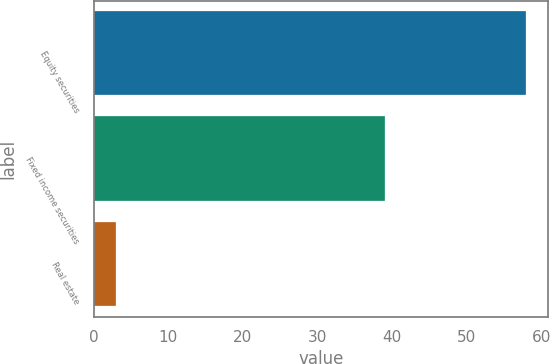Convert chart. <chart><loc_0><loc_0><loc_500><loc_500><bar_chart><fcel>Equity securities<fcel>Fixed income securities<fcel>Real estate<nl><fcel>58<fcel>39<fcel>3<nl></chart> 